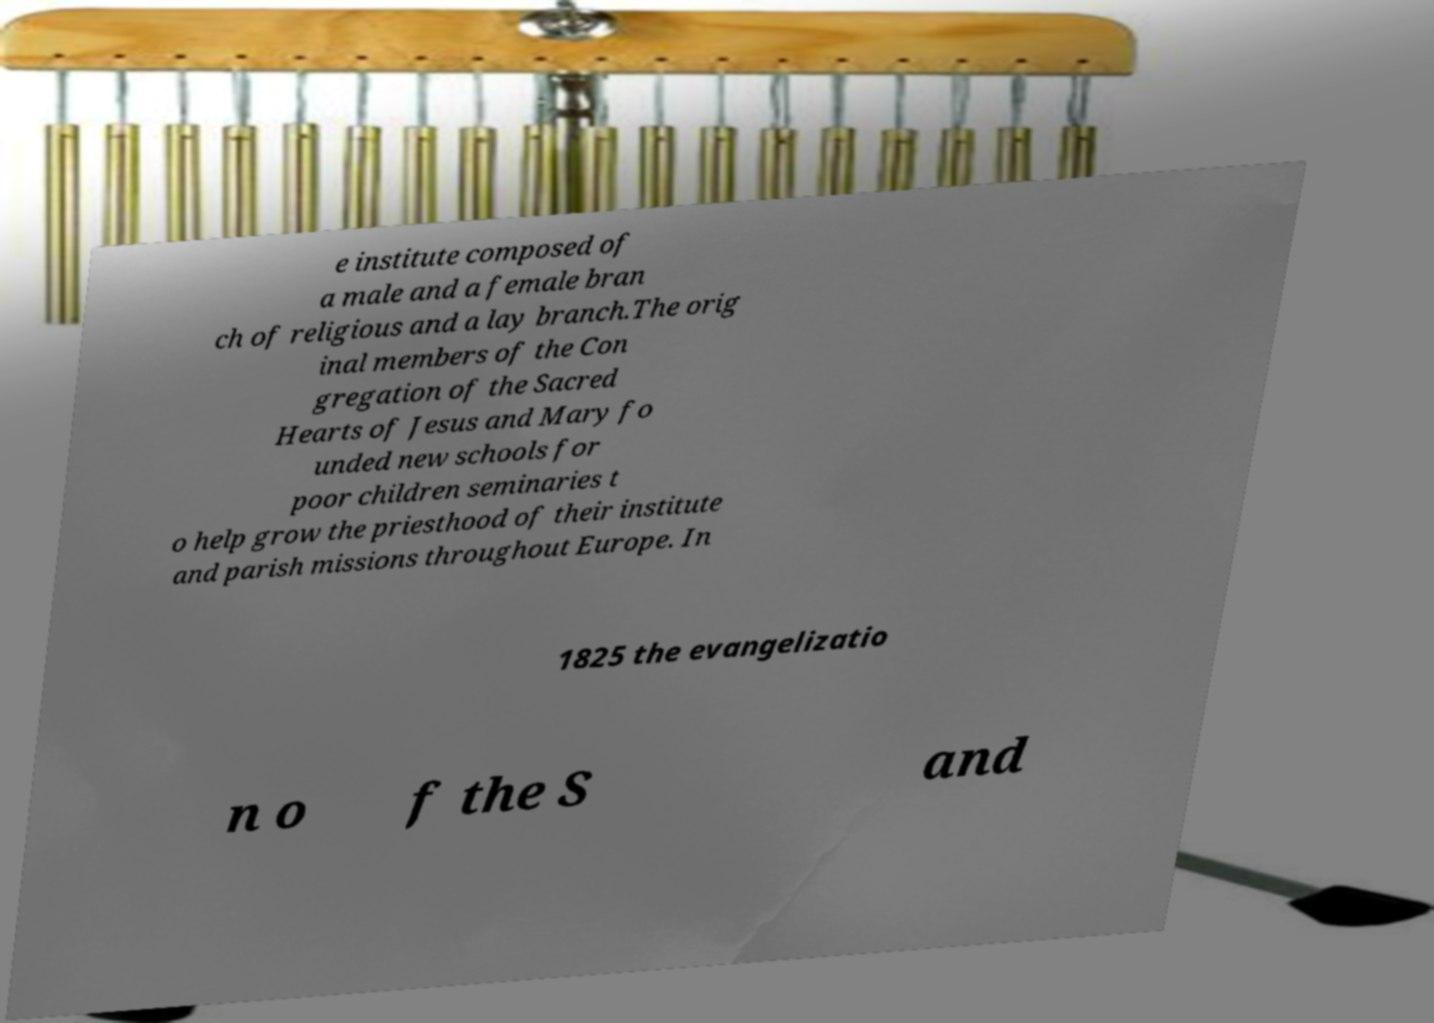For documentation purposes, I need the text within this image transcribed. Could you provide that? e institute composed of a male and a female bran ch of religious and a lay branch.The orig inal members of the Con gregation of the Sacred Hearts of Jesus and Mary fo unded new schools for poor children seminaries t o help grow the priesthood of their institute and parish missions throughout Europe. In 1825 the evangelizatio n o f the S and 